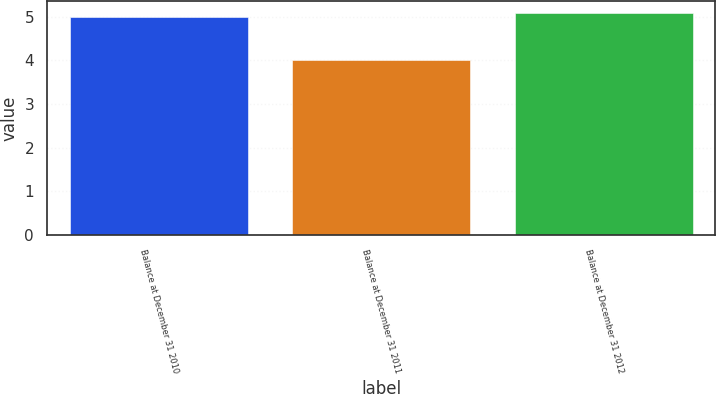Convert chart to OTSL. <chart><loc_0><loc_0><loc_500><loc_500><bar_chart><fcel>Balance at December 31 2010<fcel>Balance at December 31 2011<fcel>Balance at December 31 2012<nl><fcel>5<fcel>4<fcel>5.1<nl></chart> 